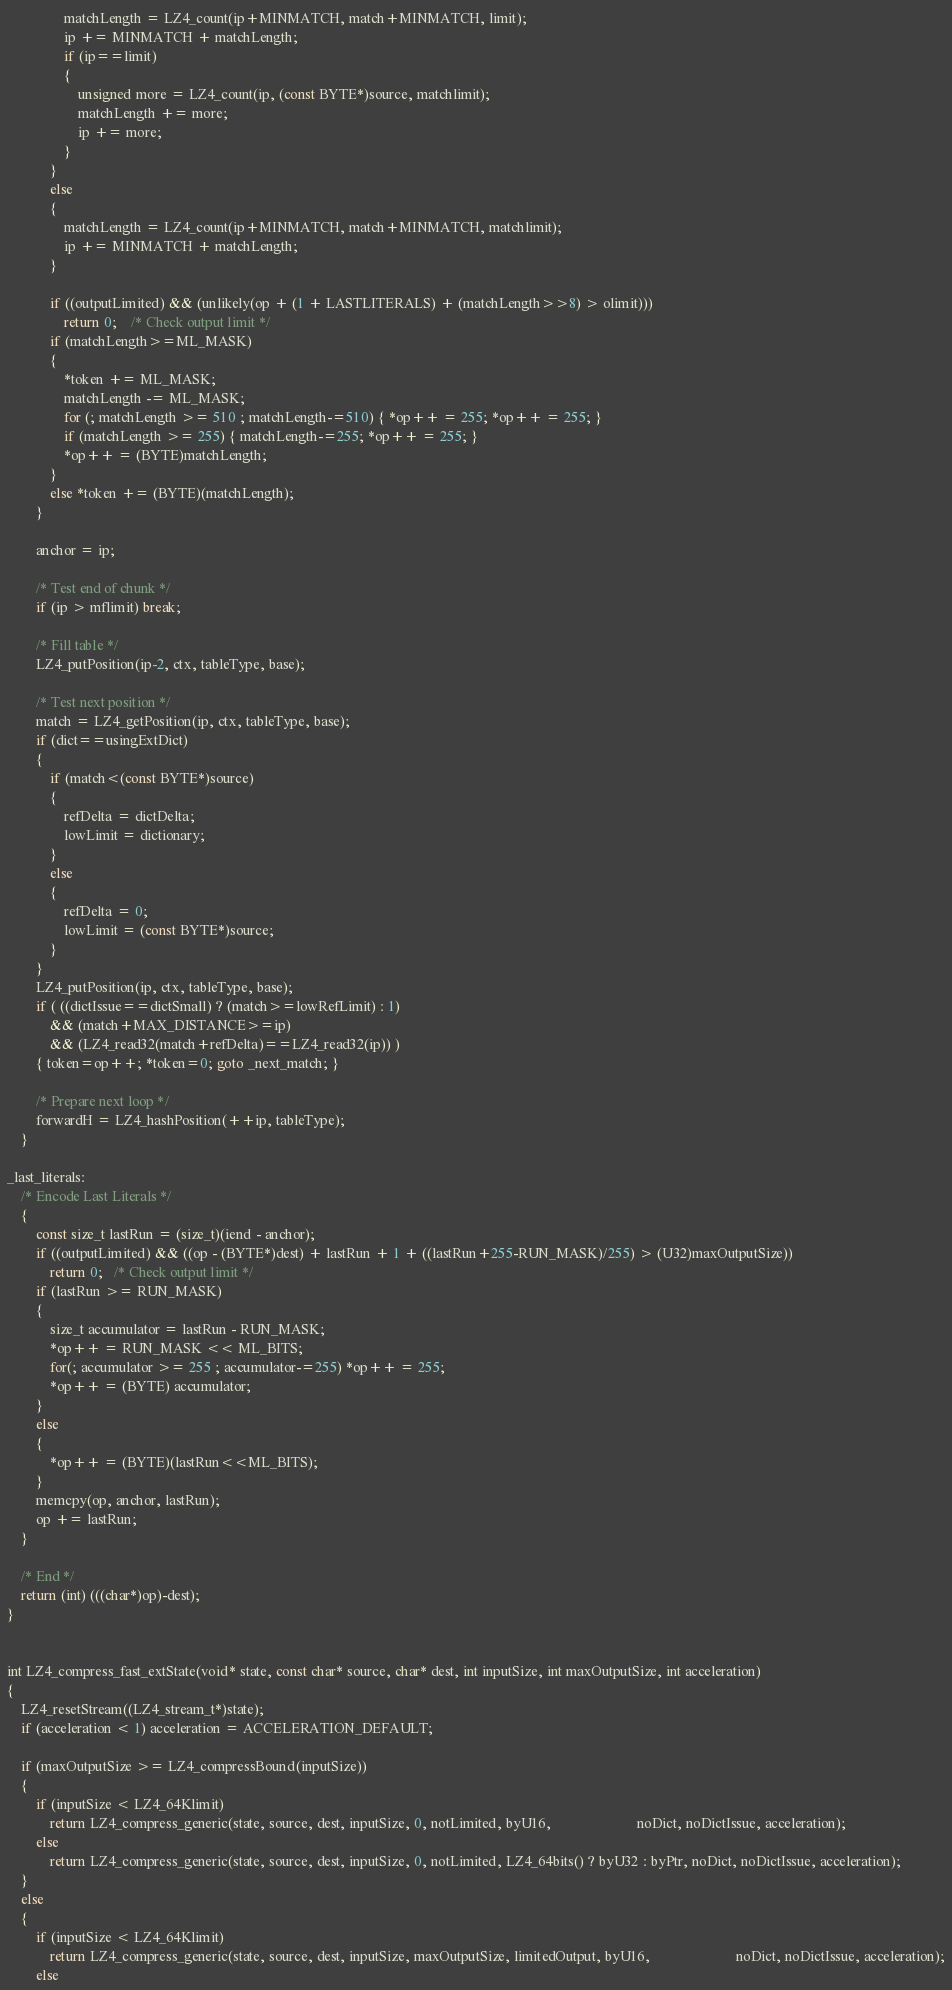<code> <loc_0><loc_0><loc_500><loc_500><_C_>                matchLength = LZ4_count(ip+MINMATCH, match+MINMATCH, limit);
                ip += MINMATCH + matchLength;
                if (ip==limit)
                {
                    unsigned more = LZ4_count(ip, (const BYTE*)source, matchlimit);
                    matchLength += more;
                    ip += more;
                }
            }
            else
            {
                matchLength = LZ4_count(ip+MINMATCH, match+MINMATCH, matchlimit);
                ip += MINMATCH + matchLength;
            }

            if ((outputLimited) && (unlikely(op + (1 + LASTLITERALS) + (matchLength>>8) > olimit)))
                return 0;    /* Check output limit */
            if (matchLength>=ML_MASK)
            {
                *token += ML_MASK;
                matchLength -= ML_MASK;
                for (; matchLength >= 510 ; matchLength-=510) { *op++ = 255; *op++ = 255; }
                if (matchLength >= 255) { matchLength-=255; *op++ = 255; }
                *op++ = (BYTE)matchLength;
            }
            else *token += (BYTE)(matchLength);
        }

        anchor = ip;

        /* Test end of chunk */
        if (ip > mflimit) break;

        /* Fill table */
        LZ4_putPosition(ip-2, ctx, tableType, base);

        /* Test next position */
        match = LZ4_getPosition(ip, ctx, tableType, base);
        if (dict==usingExtDict)
        {
            if (match<(const BYTE*)source)
            {
                refDelta = dictDelta;
                lowLimit = dictionary;
            }
            else
            {
                refDelta = 0;
                lowLimit = (const BYTE*)source;
            }
        }
        LZ4_putPosition(ip, ctx, tableType, base);
        if ( ((dictIssue==dictSmall) ? (match>=lowRefLimit) : 1)
            && (match+MAX_DISTANCE>=ip)
            && (LZ4_read32(match+refDelta)==LZ4_read32(ip)) )
        { token=op++; *token=0; goto _next_match; }

        /* Prepare next loop */
        forwardH = LZ4_hashPosition(++ip, tableType);
    }

_last_literals:
    /* Encode Last Literals */
    {
        const size_t lastRun = (size_t)(iend - anchor);
        if ((outputLimited) && ((op - (BYTE*)dest) + lastRun + 1 + ((lastRun+255-RUN_MASK)/255) > (U32)maxOutputSize))
            return 0;   /* Check output limit */
        if (lastRun >= RUN_MASK)
        {
            size_t accumulator = lastRun - RUN_MASK;
            *op++ = RUN_MASK << ML_BITS;
            for(; accumulator >= 255 ; accumulator-=255) *op++ = 255;
            *op++ = (BYTE) accumulator;
        }
        else
        {
            *op++ = (BYTE)(lastRun<<ML_BITS);
        }
        memcpy(op, anchor, lastRun);
        op += lastRun;
    }

    /* End */
    return (int) (((char*)op)-dest);
}


int LZ4_compress_fast_extState(void* state, const char* source, char* dest, int inputSize, int maxOutputSize, int acceleration)
{
    LZ4_resetStream((LZ4_stream_t*)state);
    if (acceleration < 1) acceleration = ACCELERATION_DEFAULT;

    if (maxOutputSize >= LZ4_compressBound(inputSize))
    {
        if (inputSize < LZ4_64Klimit)
            return LZ4_compress_generic(state, source, dest, inputSize, 0, notLimited, byU16,                        noDict, noDictIssue, acceleration);
        else
            return LZ4_compress_generic(state, source, dest, inputSize, 0, notLimited, LZ4_64bits() ? byU32 : byPtr, noDict, noDictIssue, acceleration);
    }
    else
    {
        if (inputSize < LZ4_64Klimit)
            return LZ4_compress_generic(state, source, dest, inputSize, maxOutputSize, limitedOutput, byU16,                        noDict, noDictIssue, acceleration);
        else</code> 